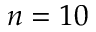<formula> <loc_0><loc_0><loc_500><loc_500>n = 1 0</formula> 